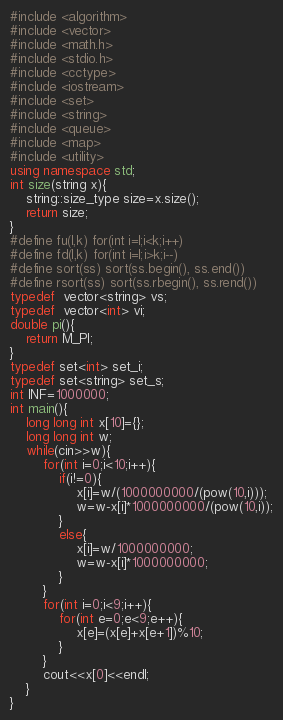<code> <loc_0><loc_0><loc_500><loc_500><_C++_>#include <algorithm>
#include <vector>
#include <math.h>
#include <stdio.h>
#include <cctype>
#include <iostream>
#include <set>
#include <string>
#include <queue>
#include <map>
#include <utility>
using namespace std;
int size(string x){
	string::size_type size=x.size();
	return size;
}
#define fu(l,k) for(int i=l;i<k;i++)
#define fd(l,k) for(int i=l;i>k;i--)
#define sort(ss) sort(ss.begin(), ss.end())
#define rsort(ss) sort(ss.rbegin(), ss.rend())
typedef  vector<string> vs;
typedef  vector<int> vi;
double pi(){
	return M_PI;
}
typedef set<int> set_i;
typedef set<string> set_s;
int INF=1000000;
int main(){
	long long int x[10]={};
	long long int w;
	while(cin>>w){
		for(int i=0;i<10;i++){
			if(i!=0){
				x[i]=w/(1000000000/(pow(10,i)));
				w=w-x[i]*1000000000/(pow(10,i));
			}
			else{
				x[i]=w/1000000000;
				w=w-x[i]*1000000000;
			}
		}
		for(int i=0;i<9;i++){
			for(int e=0;e<9;e++){
				x[e]=(x[e]+x[e+1])%10;
			}
		}
		cout<<x[0]<<endl;
	}
}</code> 